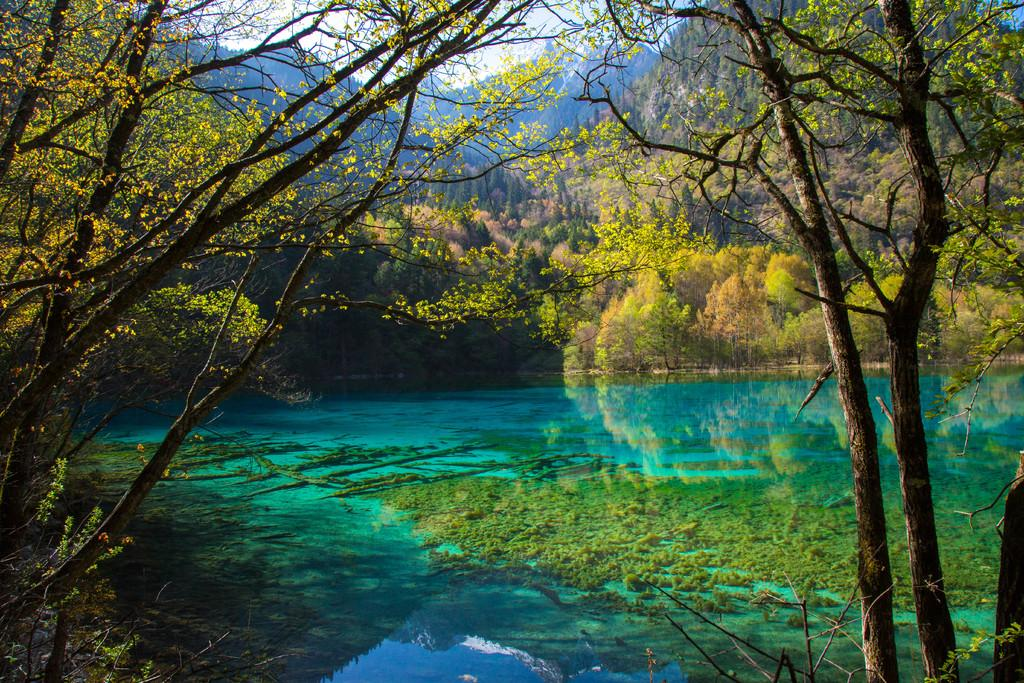What is located at the bottom of the image? There is a pond at the bottom of the image. What can be seen in the background of the image? There are trees in the background of the image. What type of religious symbol can be seen near the pond in the image? There is no religious symbol present in the image; it only features a pond and trees. How many tomatoes are growing on the trees in the image? There are no tomatoes visible in the image, as the trees are not described as fruit-bearing trees. 